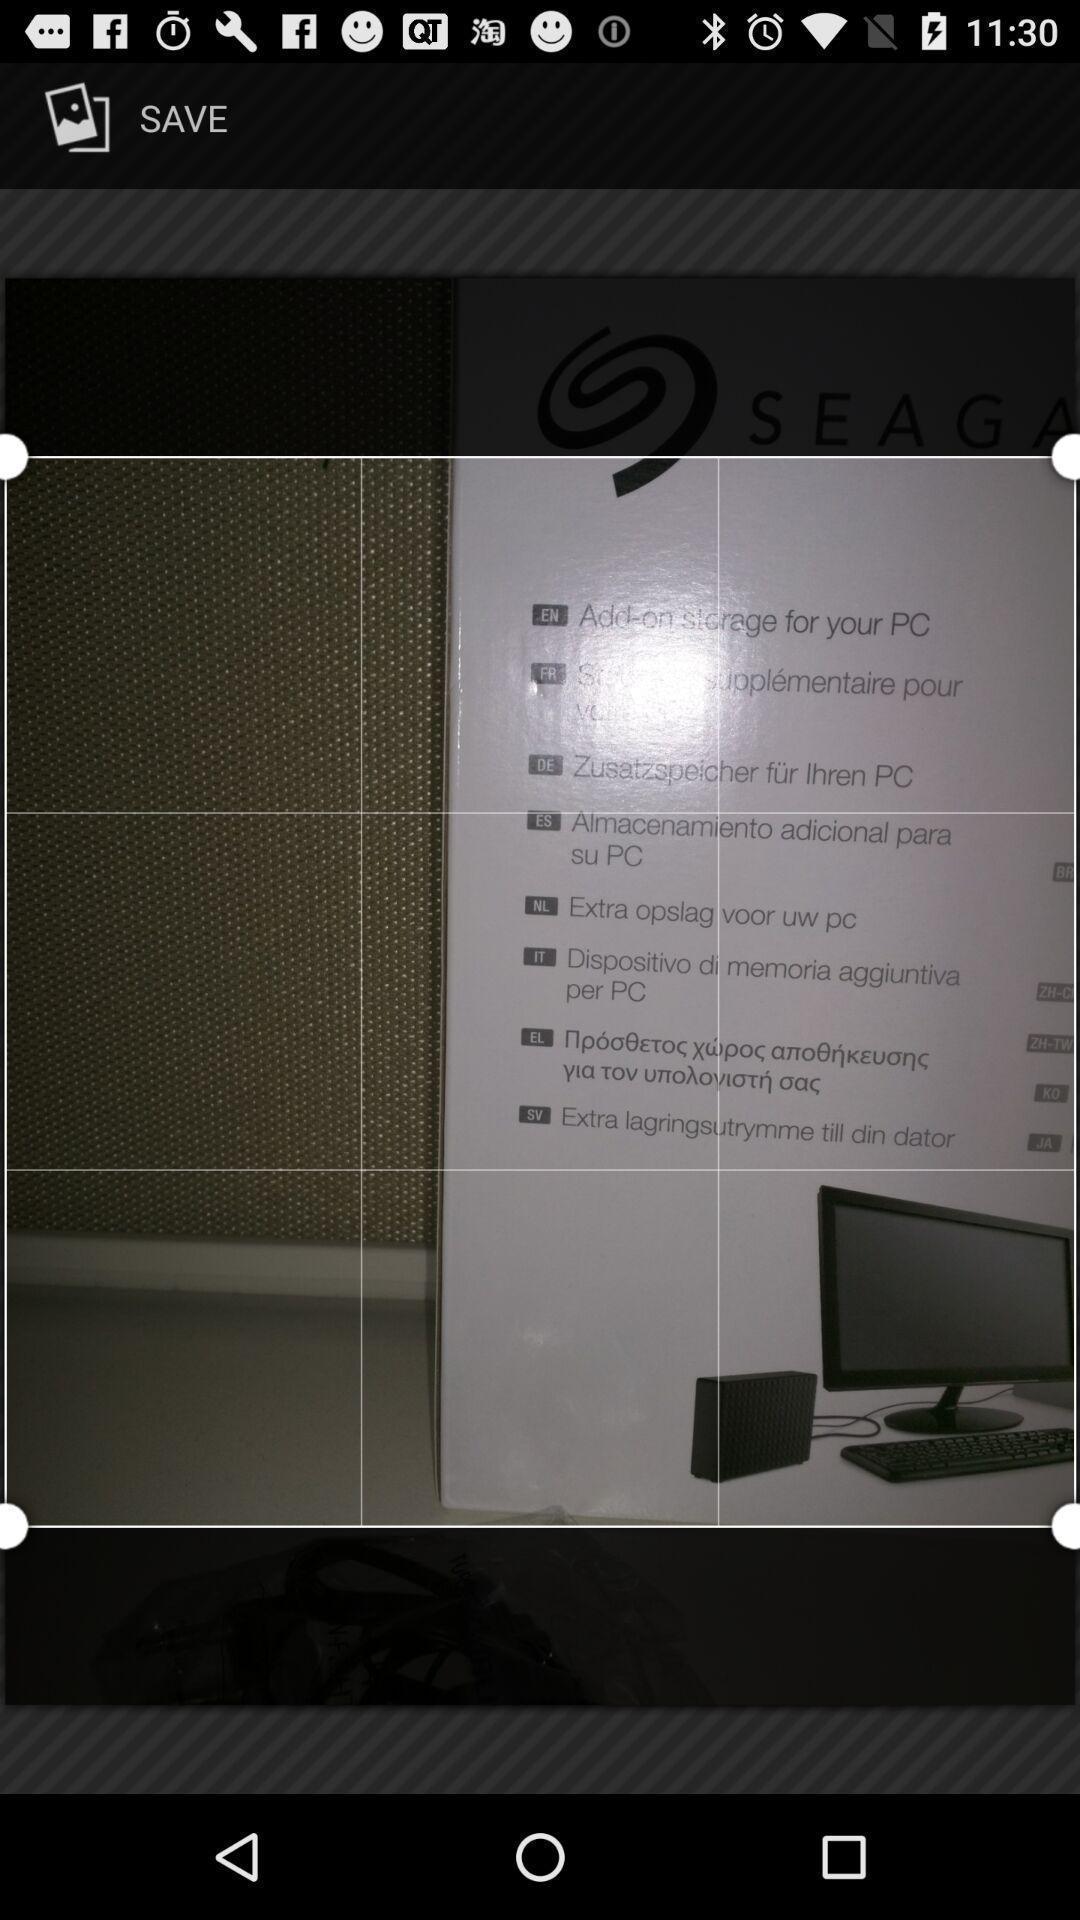Please provide a description for this image. Photo editing page. 